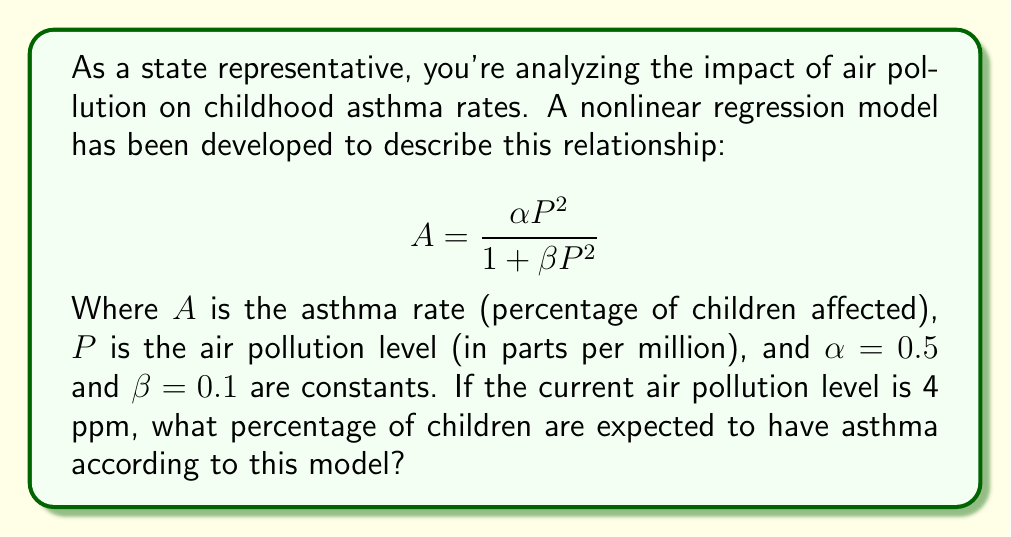Solve this math problem. To solve this problem, we'll follow these steps:

1) We have the nonlinear model:
   $$ A = \frac{\alpha P^2}{1 + \beta P^2} $$

2) We're given the following values:
   $\alpha = 0.5$
   $\beta = 0.1$
   $P = 4$ ppm

3) Let's substitute these values into our equation:
   $$ A = \frac{0.5 \cdot 4^2}{1 + 0.1 \cdot 4^2} $$

4) First, let's calculate $4^2$:
   $4^2 = 16$

5) Now our equation looks like:
   $$ A = \frac{0.5 \cdot 16}{1 + 0.1 \cdot 16} $$

6) Let's simplify the numerator and denominator separately:
   Numerator: $0.5 \cdot 16 = 8$
   Denominator: $1 + 0.1 \cdot 16 = 1 + 1.6 = 2.6$

7) Our equation is now:
   $$ A = \frac{8}{2.6} $$

8) Dividing 8 by 2.6:
   $A \approx 3.0769$

9) Since $A$ represents a percentage, we multiply by 100:
   $A \approx 3.0769 \cdot 100 \approx 30.769\%$

Therefore, according to this model, approximately 30.77% of children are expected to have asthma when the air pollution level is 4 ppm.
Answer: 30.77% 